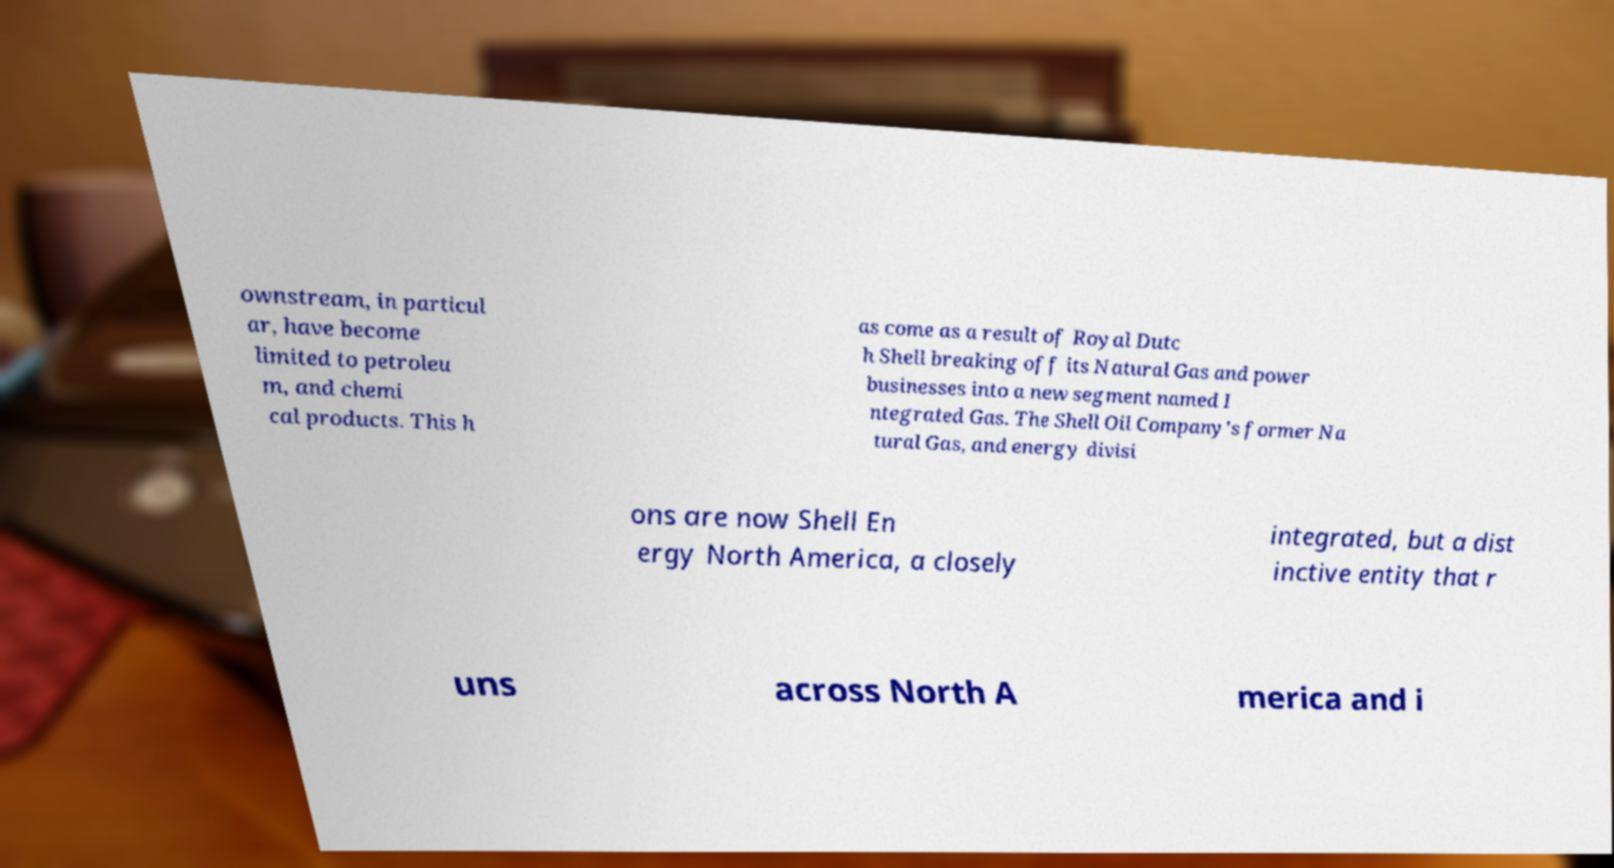For documentation purposes, I need the text within this image transcribed. Could you provide that? ownstream, in particul ar, have become limited to petroleu m, and chemi cal products. This h as come as a result of Royal Dutc h Shell breaking off its Natural Gas and power businesses into a new segment named I ntegrated Gas. The Shell Oil Company's former Na tural Gas, and energy divisi ons are now Shell En ergy North America, a closely integrated, but a dist inctive entity that r uns across North A merica and i 